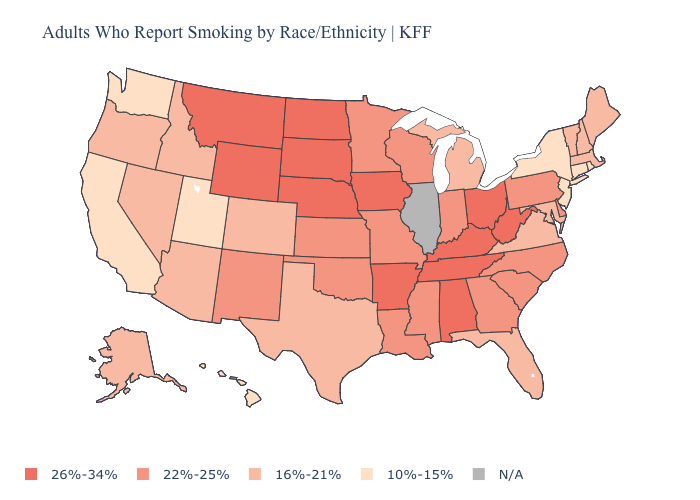What is the value of Michigan?
Short answer required. 16%-21%. Is the legend a continuous bar?
Write a very short answer. No. What is the lowest value in the West?
Give a very brief answer. 10%-15%. Among the states that border New Mexico , does Colorado have the highest value?
Give a very brief answer. No. Does South Carolina have the lowest value in the South?
Answer briefly. No. Which states hav the highest value in the South?
Concise answer only. Alabama, Arkansas, Kentucky, Tennessee, West Virginia. What is the highest value in the West ?
Concise answer only. 26%-34%. Name the states that have a value in the range N/A?
Write a very short answer. Illinois. What is the lowest value in the USA?
Give a very brief answer. 10%-15%. Does the map have missing data?
Write a very short answer. Yes. Name the states that have a value in the range 10%-15%?
Be succinct. California, Connecticut, Hawaii, New Jersey, New York, Rhode Island, Utah, Washington. 